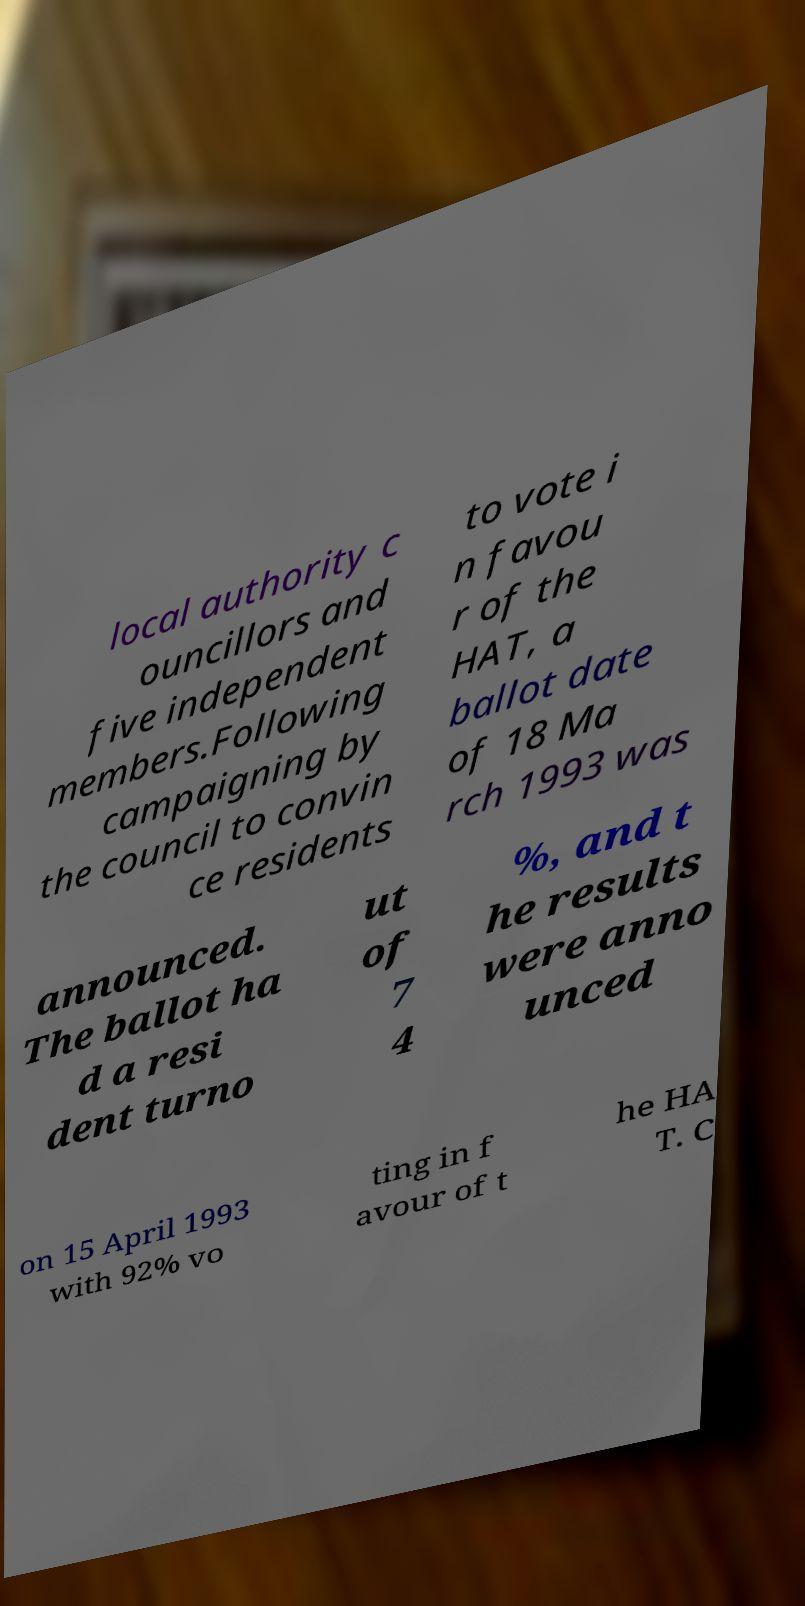I need the written content from this picture converted into text. Can you do that? local authority c ouncillors and five independent members.Following campaigning by the council to convin ce residents to vote i n favou r of the HAT, a ballot date of 18 Ma rch 1993 was announced. The ballot ha d a resi dent turno ut of 7 4 %, and t he results were anno unced on 15 April 1993 with 92% vo ting in f avour of t he HA T. C 